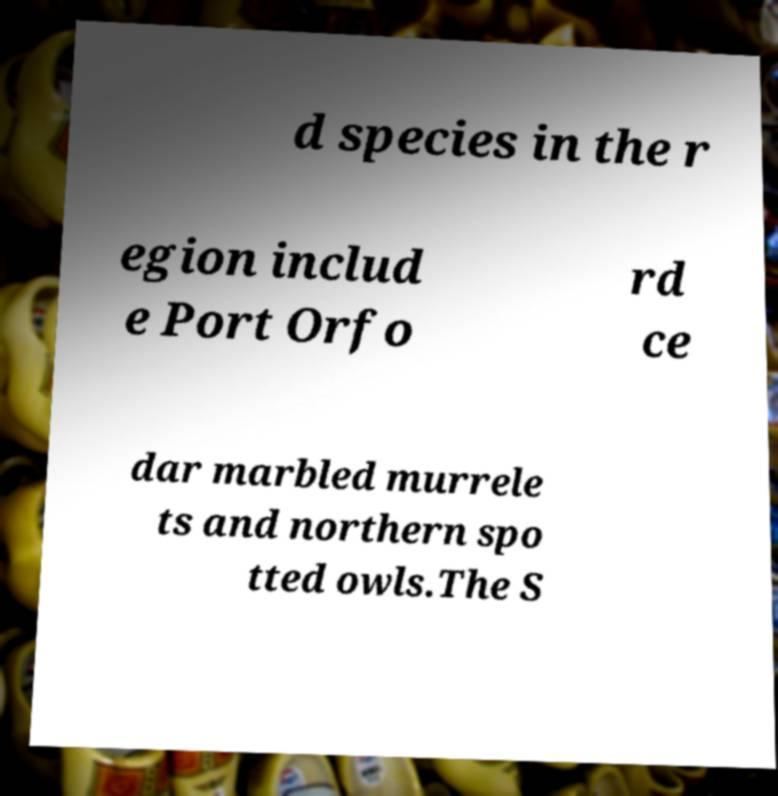What messages or text are displayed in this image? I need them in a readable, typed format. d species in the r egion includ e Port Orfo rd ce dar marbled murrele ts and northern spo tted owls.The S 